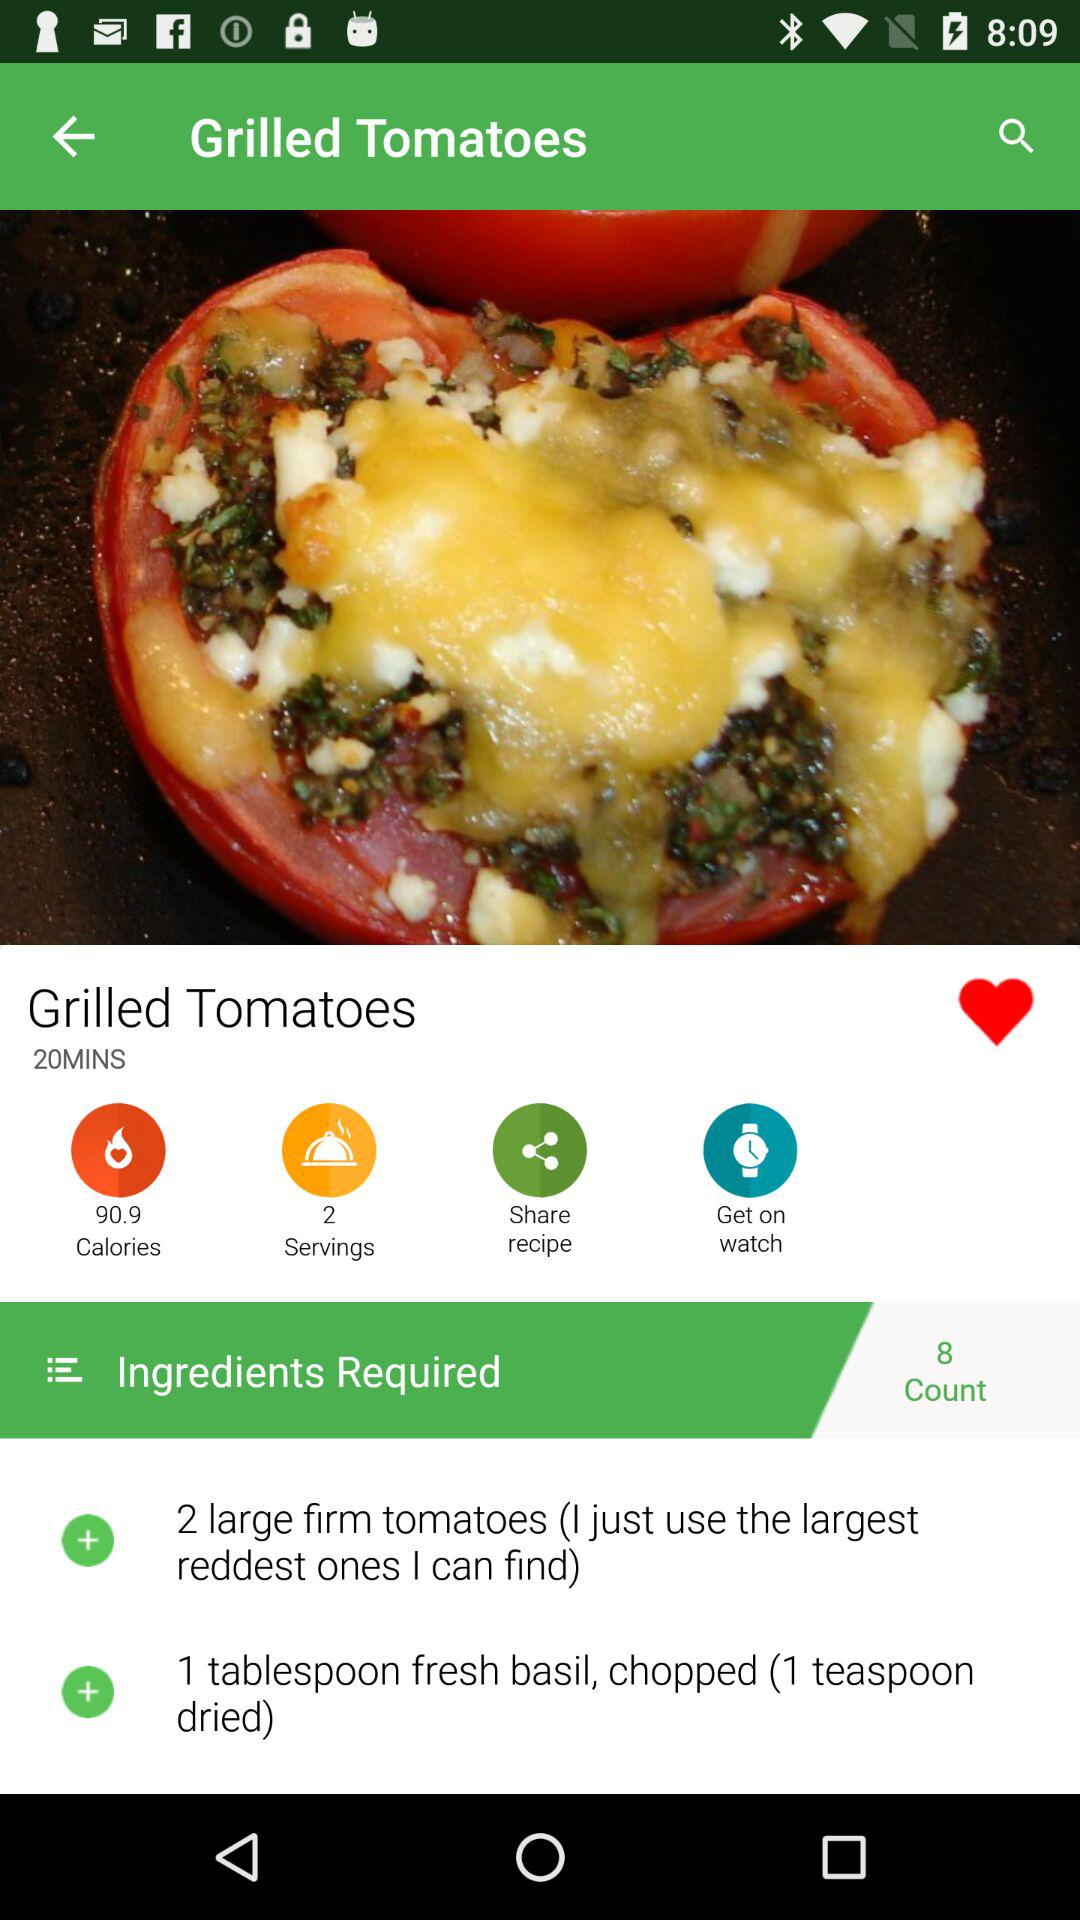How many people can the dish be served to? The dish can be served to 2 people. 